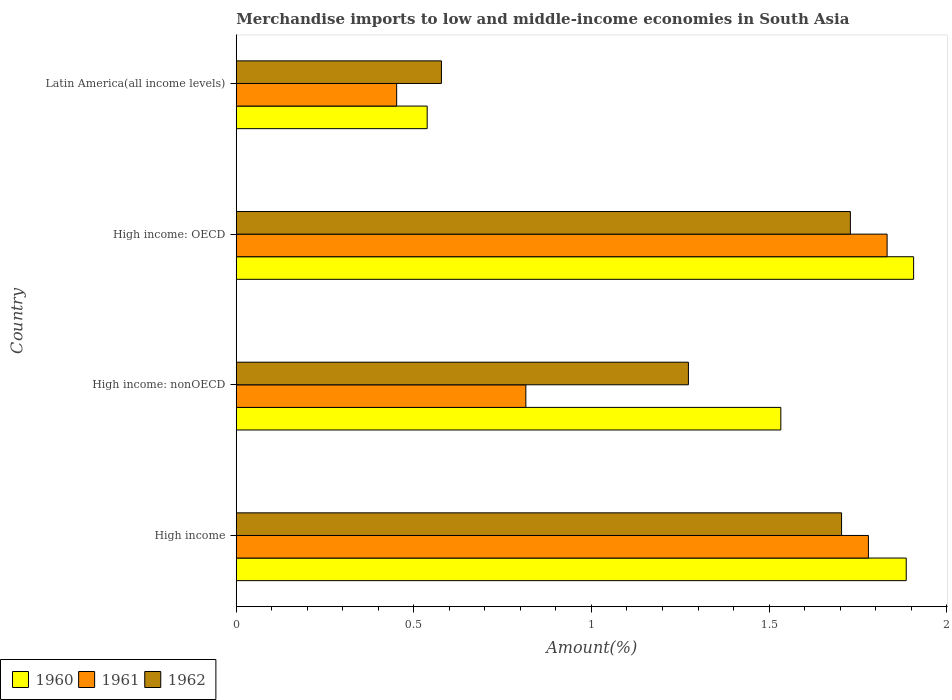Are the number of bars per tick equal to the number of legend labels?
Give a very brief answer. Yes. What is the label of the 3rd group of bars from the top?
Make the answer very short. High income: nonOECD. In how many cases, is the number of bars for a given country not equal to the number of legend labels?
Your response must be concise. 0. What is the percentage of amount earned from merchandise imports in 1960 in Latin America(all income levels)?
Make the answer very short. 0.54. Across all countries, what is the maximum percentage of amount earned from merchandise imports in 1960?
Give a very brief answer. 1.91. Across all countries, what is the minimum percentage of amount earned from merchandise imports in 1961?
Your response must be concise. 0.45. In which country was the percentage of amount earned from merchandise imports in 1961 maximum?
Offer a terse response. High income: OECD. In which country was the percentage of amount earned from merchandise imports in 1962 minimum?
Ensure brevity in your answer.  Latin America(all income levels). What is the total percentage of amount earned from merchandise imports in 1961 in the graph?
Offer a very short reply. 4.88. What is the difference between the percentage of amount earned from merchandise imports in 1960 in High income: OECD and that in High income: nonOECD?
Ensure brevity in your answer.  0.37. What is the difference between the percentage of amount earned from merchandise imports in 1961 in High income: OECD and the percentage of amount earned from merchandise imports in 1960 in Latin America(all income levels)?
Provide a short and direct response. 1.29. What is the average percentage of amount earned from merchandise imports in 1961 per country?
Your answer should be compact. 1.22. What is the difference between the percentage of amount earned from merchandise imports in 1960 and percentage of amount earned from merchandise imports in 1962 in High income?
Give a very brief answer. 0.18. In how many countries, is the percentage of amount earned from merchandise imports in 1961 greater than 1.4 %?
Ensure brevity in your answer.  2. What is the ratio of the percentage of amount earned from merchandise imports in 1961 in High income to that in Latin America(all income levels)?
Ensure brevity in your answer.  3.94. Is the difference between the percentage of amount earned from merchandise imports in 1960 in High income and Latin America(all income levels) greater than the difference between the percentage of amount earned from merchandise imports in 1962 in High income and Latin America(all income levels)?
Provide a short and direct response. Yes. What is the difference between the highest and the second highest percentage of amount earned from merchandise imports in 1960?
Your answer should be compact. 0.02. What is the difference between the highest and the lowest percentage of amount earned from merchandise imports in 1960?
Your response must be concise. 1.37. What does the 1st bar from the bottom in High income represents?
Provide a succinct answer. 1960. Is it the case that in every country, the sum of the percentage of amount earned from merchandise imports in 1960 and percentage of amount earned from merchandise imports in 1962 is greater than the percentage of amount earned from merchandise imports in 1961?
Provide a short and direct response. Yes. Are all the bars in the graph horizontal?
Make the answer very short. Yes. How many countries are there in the graph?
Your answer should be compact. 4. Does the graph contain any zero values?
Give a very brief answer. No. What is the title of the graph?
Offer a very short reply. Merchandise imports to low and middle-income economies in South Asia. Does "2010" appear as one of the legend labels in the graph?
Your answer should be compact. No. What is the label or title of the X-axis?
Ensure brevity in your answer.  Amount(%). What is the label or title of the Y-axis?
Provide a succinct answer. Country. What is the Amount(%) in 1960 in High income?
Your response must be concise. 1.89. What is the Amount(%) in 1961 in High income?
Offer a terse response. 1.78. What is the Amount(%) of 1962 in High income?
Keep it short and to the point. 1.7. What is the Amount(%) in 1960 in High income: nonOECD?
Offer a very short reply. 1.53. What is the Amount(%) in 1961 in High income: nonOECD?
Ensure brevity in your answer.  0.82. What is the Amount(%) of 1962 in High income: nonOECD?
Make the answer very short. 1.27. What is the Amount(%) in 1960 in High income: OECD?
Provide a succinct answer. 1.91. What is the Amount(%) in 1961 in High income: OECD?
Your answer should be very brief. 1.83. What is the Amount(%) in 1962 in High income: OECD?
Offer a terse response. 1.73. What is the Amount(%) in 1960 in Latin America(all income levels)?
Ensure brevity in your answer.  0.54. What is the Amount(%) in 1961 in Latin America(all income levels)?
Provide a succinct answer. 0.45. What is the Amount(%) in 1962 in Latin America(all income levels)?
Provide a succinct answer. 0.58. Across all countries, what is the maximum Amount(%) in 1960?
Offer a terse response. 1.91. Across all countries, what is the maximum Amount(%) in 1961?
Your answer should be very brief. 1.83. Across all countries, what is the maximum Amount(%) of 1962?
Give a very brief answer. 1.73. Across all countries, what is the minimum Amount(%) of 1960?
Keep it short and to the point. 0.54. Across all countries, what is the minimum Amount(%) of 1961?
Keep it short and to the point. 0.45. Across all countries, what is the minimum Amount(%) of 1962?
Your answer should be compact. 0.58. What is the total Amount(%) in 1960 in the graph?
Provide a succinct answer. 5.86. What is the total Amount(%) of 1961 in the graph?
Make the answer very short. 4.88. What is the total Amount(%) of 1962 in the graph?
Keep it short and to the point. 5.28. What is the difference between the Amount(%) in 1960 in High income and that in High income: nonOECD?
Provide a succinct answer. 0.35. What is the difference between the Amount(%) of 1961 in High income and that in High income: nonOECD?
Offer a terse response. 0.96. What is the difference between the Amount(%) in 1962 in High income and that in High income: nonOECD?
Ensure brevity in your answer.  0.43. What is the difference between the Amount(%) in 1960 in High income and that in High income: OECD?
Offer a terse response. -0.02. What is the difference between the Amount(%) in 1961 in High income and that in High income: OECD?
Your answer should be compact. -0.05. What is the difference between the Amount(%) in 1962 in High income and that in High income: OECD?
Ensure brevity in your answer.  -0.02. What is the difference between the Amount(%) in 1960 in High income and that in Latin America(all income levels)?
Offer a terse response. 1.35. What is the difference between the Amount(%) in 1961 in High income and that in Latin America(all income levels)?
Your answer should be compact. 1.33. What is the difference between the Amount(%) in 1962 in High income and that in Latin America(all income levels)?
Offer a very short reply. 1.13. What is the difference between the Amount(%) of 1960 in High income: nonOECD and that in High income: OECD?
Give a very brief answer. -0.37. What is the difference between the Amount(%) of 1961 in High income: nonOECD and that in High income: OECD?
Your response must be concise. -1.02. What is the difference between the Amount(%) in 1962 in High income: nonOECD and that in High income: OECD?
Your answer should be compact. -0.46. What is the difference between the Amount(%) in 1961 in High income: nonOECD and that in Latin America(all income levels)?
Keep it short and to the point. 0.36. What is the difference between the Amount(%) of 1962 in High income: nonOECD and that in Latin America(all income levels)?
Make the answer very short. 0.7. What is the difference between the Amount(%) of 1960 in High income: OECD and that in Latin America(all income levels)?
Provide a succinct answer. 1.37. What is the difference between the Amount(%) in 1961 in High income: OECD and that in Latin America(all income levels)?
Offer a terse response. 1.38. What is the difference between the Amount(%) in 1962 in High income: OECD and that in Latin America(all income levels)?
Offer a very short reply. 1.15. What is the difference between the Amount(%) of 1960 in High income and the Amount(%) of 1961 in High income: nonOECD?
Offer a terse response. 1.07. What is the difference between the Amount(%) of 1960 in High income and the Amount(%) of 1962 in High income: nonOECD?
Offer a terse response. 0.61. What is the difference between the Amount(%) of 1961 in High income and the Amount(%) of 1962 in High income: nonOECD?
Make the answer very short. 0.51. What is the difference between the Amount(%) of 1960 in High income and the Amount(%) of 1961 in High income: OECD?
Keep it short and to the point. 0.05. What is the difference between the Amount(%) in 1960 in High income and the Amount(%) in 1962 in High income: OECD?
Offer a very short reply. 0.16. What is the difference between the Amount(%) in 1961 in High income and the Amount(%) in 1962 in High income: OECD?
Ensure brevity in your answer.  0.05. What is the difference between the Amount(%) in 1960 in High income and the Amount(%) in 1961 in Latin America(all income levels)?
Offer a terse response. 1.43. What is the difference between the Amount(%) in 1960 in High income and the Amount(%) in 1962 in Latin America(all income levels)?
Give a very brief answer. 1.31. What is the difference between the Amount(%) in 1961 in High income and the Amount(%) in 1962 in Latin America(all income levels)?
Offer a very short reply. 1.2. What is the difference between the Amount(%) in 1960 in High income: nonOECD and the Amount(%) in 1961 in High income: OECD?
Give a very brief answer. -0.3. What is the difference between the Amount(%) in 1960 in High income: nonOECD and the Amount(%) in 1962 in High income: OECD?
Give a very brief answer. -0.2. What is the difference between the Amount(%) in 1961 in High income: nonOECD and the Amount(%) in 1962 in High income: OECD?
Your answer should be very brief. -0.91. What is the difference between the Amount(%) of 1960 in High income: nonOECD and the Amount(%) of 1961 in Latin America(all income levels)?
Provide a succinct answer. 1.08. What is the difference between the Amount(%) in 1960 in High income: nonOECD and the Amount(%) in 1962 in Latin America(all income levels)?
Provide a short and direct response. 0.96. What is the difference between the Amount(%) in 1961 in High income: nonOECD and the Amount(%) in 1962 in Latin America(all income levels)?
Provide a short and direct response. 0.24. What is the difference between the Amount(%) of 1960 in High income: OECD and the Amount(%) of 1961 in Latin America(all income levels)?
Provide a succinct answer. 1.46. What is the difference between the Amount(%) in 1960 in High income: OECD and the Amount(%) in 1962 in Latin America(all income levels)?
Offer a terse response. 1.33. What is the difference between the Amount(%) in 1961 in High income: OECD and the Amount(%) in 1962 in Latin America(all income levels)?
Provide a succinct answer. 1.25. What is the average Amount(%) in 1960 per country?
Give a very brief answer. 1.47. What is the average Amount(%) in 1961 per country?
Your answer should be compact. 1.22. What is the average Amount(%) of 1962 per country?
Keep it short and to the point. 1.32. What is the difference between the Amount(%) of 1960 and Amount(%) of 1961 in High income?
Offer a terse response. 0.11. What is the difference between the Amount(%) in 1960 and Amount(%) in 1962 in High income?
Provide a short and direct response. 0.18. What is the difference between the Amount(%) in 1961 and Amount(%) in 1962 in High income?
Give a very brief answer. 0.08. What is the difference between the Amount(%) in 1960 and Amount(%) in 1961 in High income: nonOECD?
Your answer should be very brief. 0.72. What is the difference between the Amount(%) in 1960 and Amount(%) in 1962 in High income: nonOECD?
Offer a terse response. 0.26. What is the difference between the Amount(%) of 1961 and Amount(%) of 1962 in High income: nonOECD?
Make the answer very short. -0.46. What is the difference between the Amount(%) of 1960 and Amount(%) of 1961 in High income: OECD?
Provide a short and direct response. 0.07. What is the difference between the Amount(%) of 1960 and Amount(%) of 1962 in High income: OECD?
Give a very brief answer. 0.18. What is the difference between the Amount(%) of 1961 and Amount(%) of 1962 in High income: OECD?
Provide a succinct answer. 0.1. What is the difference between the Amount(%) in 1960 and Amount(%) in 1961 in Latin America(all income levels)?
Ensure brevity in your answer.  0.09. What is the difference between the Amount(%) of 1960 and Amount(%) of 1962 in Latin America(all income levels)?
Your answer should be very brief. -0.04. What is the difference between the Amount(%) in 1961 and Amount(%) in 1962 in Latin America(all income levels)?
Offer a terse response. -0.13. What is the ratio of the Amount(%) of 1960 in High income to that in High income: nonOECD?
Your answer should be compact. 1.23. What is the ratio of the Amount(%) in 1961 in High income to that in High income: nonOECD?
Make the answer very short. 2.18. What is the ratio of the Amount(%) in 1962 in High income to that in High income: nonOECD?
Your answer should be very brief. 1.34. What is the ratio of the Amount(%) in 1961 in High income to that in High income: OECD?
Your answer should be very brief. 0.97. What is the ratio of the Amount(%) of 1962 in High income to that in High income: OECD?
Offer a very short reply. 0.99. What is the ratio of the Amount(%) of 1960 in High income to that in Latin America(all income levels)?
Your answer should be compact. 3.51. What is the ratio of the Amount(%) in 1961 in High income to that in Latin America(all income levels)?
Your answer should be compact. 3.94. What is the ratio of the Amount(%) in 1962 in High income to that in Latin America(all income levels)?
Your response must be concise. 2.95. What is the ratio of the Amount(%) of 1960 in High income: nonOECD to that in High income: OECD?
Give a very brief answer. 0.8. What is the ratio of the Amount(%) of 1961 in High income: nonOECD to that in High income: OECD?
Offer a terse response. 0.44. What is the ratio of the Amount(%) in 1962 in High income: nonOECD to that in High income: OECD?
Offer a terse response. 0.74. What is the ratio of the Amount(%) in 1960 in High income: nonOECD to that in Latin America(all income levels)?
Provide a short and direct response. 2.85. What is the ratio of the Amount(%) of 1961 in High income: nonOECD to that in Latin America(all income levels)?
Keep it short and to the point. 1.81. What is the ratio of the Amount(%) in 1962 in High income: nonOECD to that in Latin America(all income levels)?
Your answer should be compact. 2.2. What is the ratio of the Amount(%) in 1960 in High income: OECD to that in Latin America(all income levels)?
Your answer should be compact. 3.55. What is the ratio of the Amount(%) of 1961 in High income: OECD to that in Latin America(all income levels)?
Give a very brief answer. 4.06. What is the ratio of the Amount(%) in 1962 in High income: OECD to that in Latin America(all income levels)?
Offer a very short reply. 2.99. What is the difference between the highest and the second highest Amount(%) in 1960?
Your answer should be compact. 0.02. What is the difference between the highest and the second highest Amount(%) in 1961?
Provide a short and direct response. 0.05. What is the difference between the highest and the second highest Amount(%) of 1962?
Make the answer very short. 0.02. What is the difference between the highest and the lowest Amount(%) in 1960?
Provide a succinct answer. 1.37. What is the difference between the highest and the lowest Amount(%) of 1961?
Your answer should be compact. 1.38. What is the difference between the highest and the lowest Amount(%) of 1962?
Provide a succinct answer. 1.15. 